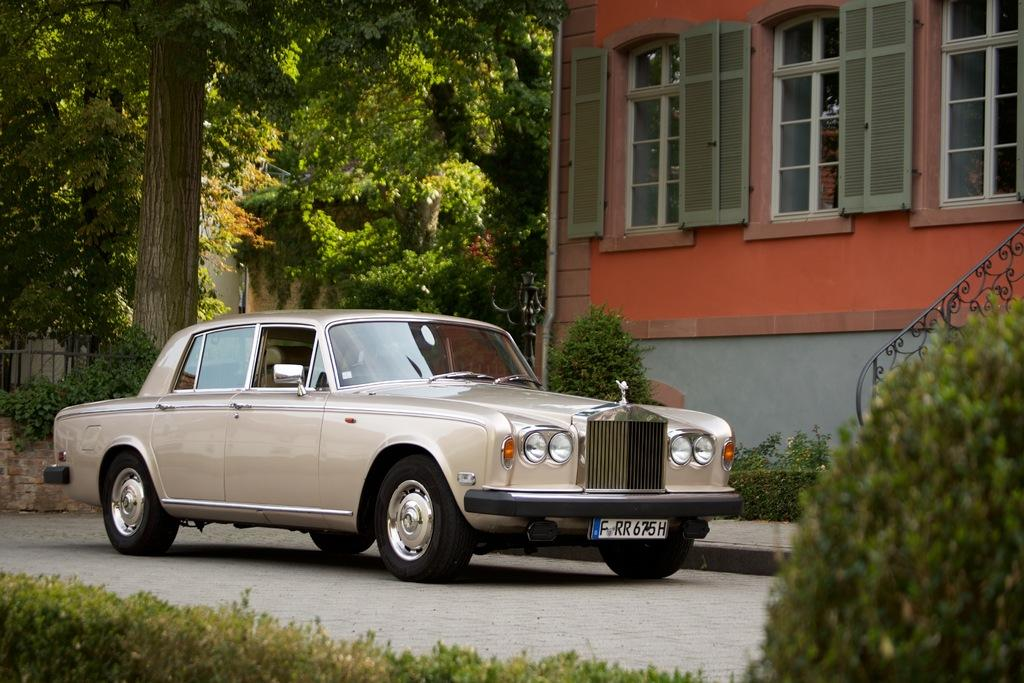What is the main subject of the picture? The main subject of the picture is a car. What can be seen in the right corner of the picture? There is a building in the right corner of the picture. What is visible in the background of the picture? There are trees, a fence, and another building in the background of the picture. Where is the cat sitting on the shelf in the image? There is no cat or shelf present in the image. What type of crook is visible in the image? There is no crook present in the image. 